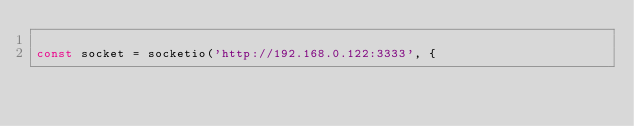Convert code to text. <code><loc_0><loc_0><loc_500><loc_500><_JavaScript_>
const socket = socketio('http://192.168.0.122:3333', {</code> 